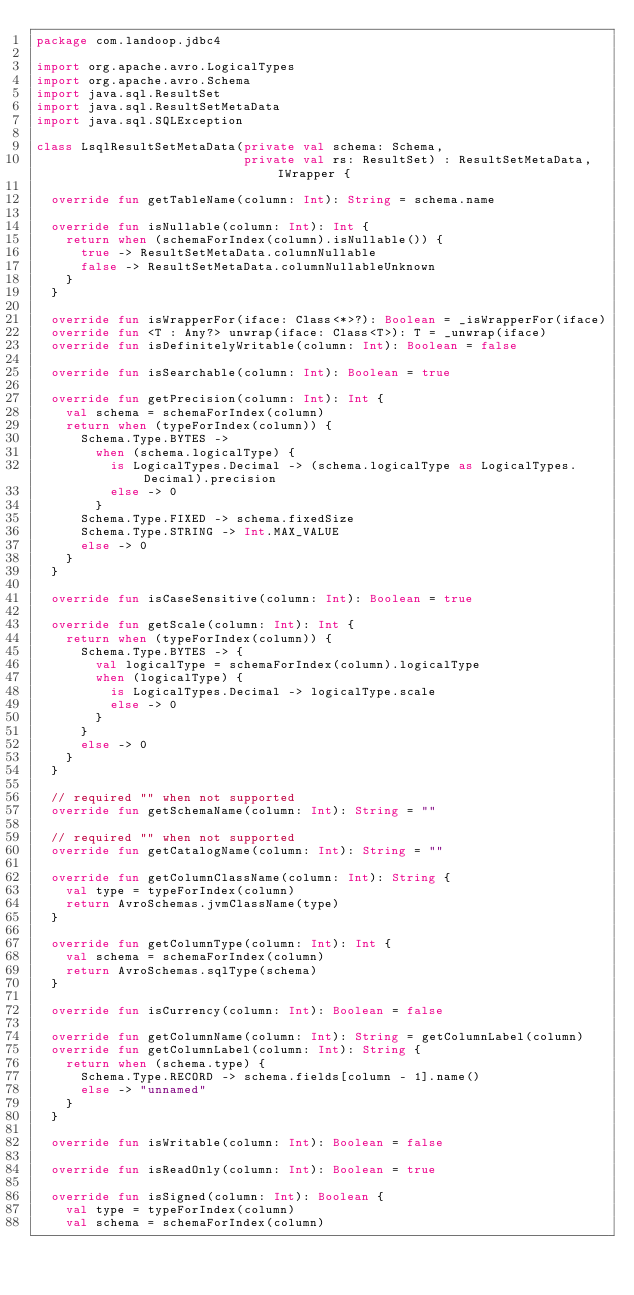<code> <loc_0><loc_0><loc_500><loc_500><_Kotlin_>package com.landoop.jdbc4

import org.apache.avro.LogicalTypes
import org.apache.avro.Schema
import java.sql.ResultSet
import java.sql.ResultSetMetaData
import java.sql.SQLException

class LsqlResultSetMetaData(private val schema: Schema,
                            private val rs: ResultSet) : ResultSetMetaData, IWrapper {

  override fun getTableName(column: Int): String = schema.name

  override fun isNullable(column: Int): Int {
    return when (schemaForIndex(column).isNullable()) {
      true -> ResultSetMetaData.columnNullable
      false -> ResultSetMetaData.columnNullableUnknown
    }
  }

  override fun isWrapperFor(iface: Class<*>?): Boolean = _isWrapperFor(iface)
  override fun <T : Any?> unwrap(iface: Class<T>): T = _unwrap(iface)
  override fun isDefinitelyWritable(column: Int): Boolean = false

  override fun isSearchable(column: Int): Boolean = true

  override fun getPrecision(column: Int): Int {
    val schema = schemaForIndex(column)
    return when (typeForIndex(column)) {
      Schema.Type.BYTES ->
        when (schema.logicalType) {
          is LogicalTypes.Decimal -> (schema.logicalType as LogicalTypes.Decimal).precision
          else -> 0
        }
      Schema.Type.FIXED -> schema.fixedSize
      Schema.Type.STRING -> Int.MAX_VALUE
      else -> 0
    }
  }

  override fun isCaseSensitive(column: Int): Boolean = true

  override fun getScale(column: Int): Int {
    return when (typeForIndex(column)) {
      Schema.Type.BYTES -> {
        val logicalType = schemaForIndex(column).logicalType
        when (logicalType) {
          is LogicalTypes.Decimal -> logicalType.scale
          else -> 0
        }
      }
      else -> 0
    }
  }

  // required "" when not supported
  override fun getSchemaName(column: Int): String = ""

  // required "" when not supported
  override fun getCatalogName(column: Int): String = ""

  override fun getColumnClassName(column: Int): String {
    val type = typeForIndex(column)
    return AvroSchemas.jvmClassName(type)
  }

  override fun getColumnType(column: Int): Int {
    val schema = schemaForIndex(column)
    return AvroSchemas.sqlType(schema)
  }

  override fun isCurrency(column: Int): Boolean = false

  override fun getColumnName(column: Int): String = getColumnLabel(column)
  override fun getColumnLabel(column: Int): String {
    return when (schema.type) {
      Schema.Type.RECORD -> schema.fields[column - 1].name()
      else -> "unnamed"
    }
  }

  override fun isWritable(column: Int): Boolean = false

  override fun isReadOnly(column: Int): Boolean = true

  override fun isSigned(column: Int): Boolean {
    val type = typeForIndex(column)
    val schema = schemaForIndex(column)</code> 